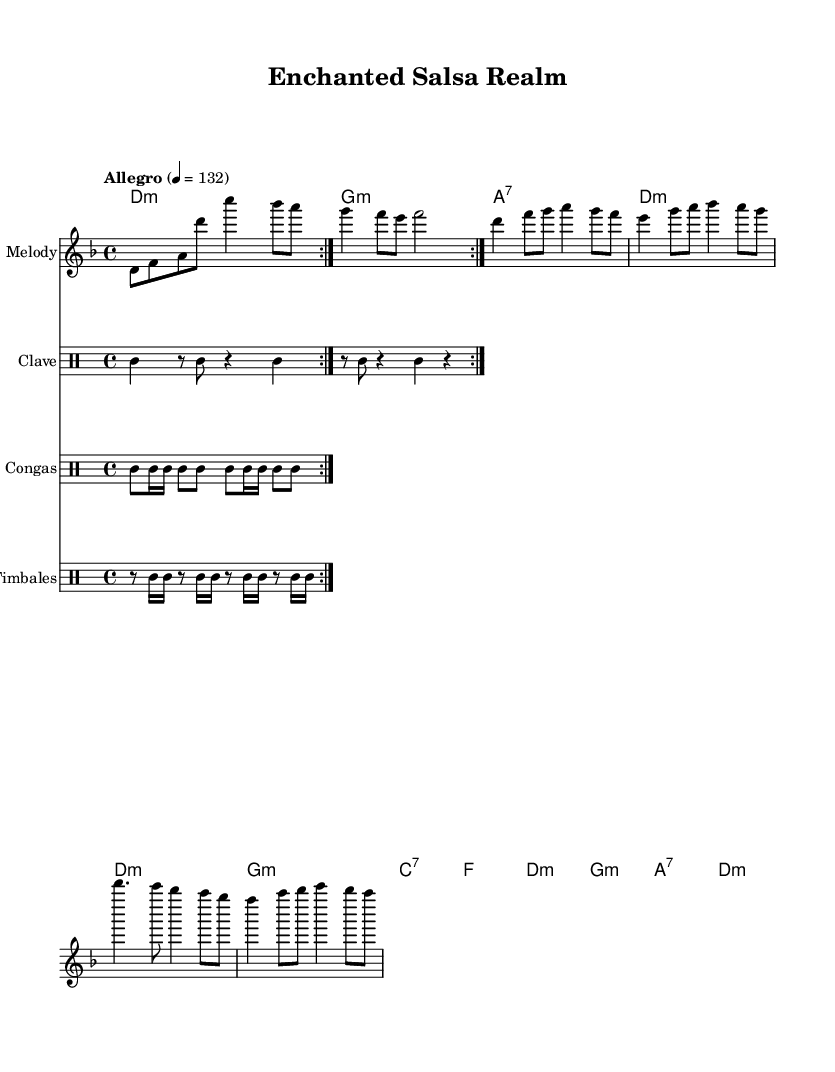What is the key signature of this music? The key signature is D minor, indicated by the presence of one flat. It can be confirmed by looking at the initial part of the staff where the key signature is displayed.
Answer: D minor What is the time signature of this music? The time signature is 4/4, which can be found at the beginning of the score, indicating that there are four beats in a measure and a quarter note gets one beat.
Answer: 4/4 What tempo marking is given for this piece? The tempo marking is "Allegro," which is indicated in the score along with the metronome marking of 132 beats per minute.
Answer: Allegro How many measures are in the chorus section? The chorus section consists of 4 measures. This can be calculated by counting the individual measures in the chorus lyrics segment of the score.
Answer: 4 What instruments are featured in the percussion section? The percussion section includes clave, congas, and timbales, as indicated in the separate staves labeled for each percussion instrument.
Answer: Clave, congas, timbales What magical creatures are referenced in the lyrics? The lyrics reference elves in the phrase "Where the elves dance in moonlight," specifically referencing a magical creature associated with enchanted realms.
Answer: Elves Which section of the song contains the lyrics about enchanted realms? The chorus section contains lyrics about enchanted realms with the line "Enchanted realms beyond compare," highlighting the theme of magic and fantasy.
Answer: Chorus 